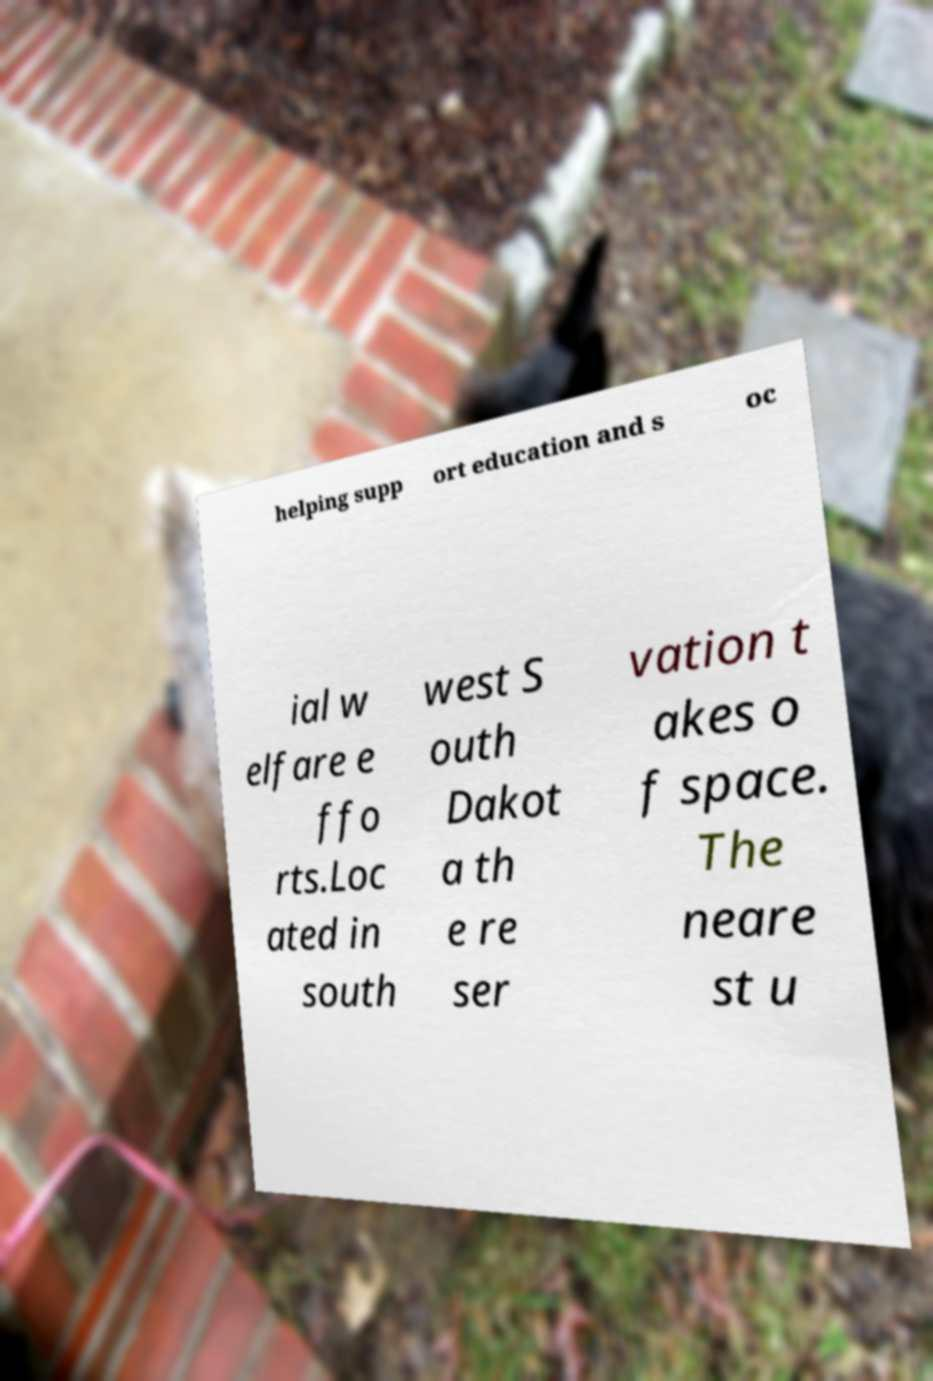Please identify and transcribe the text found in this image. helping supp ort education and s oc ial w elfare e ffo rts.Loc ated in south west S outh Dakot a th e re ser vation t akes o f space. The neare st u 